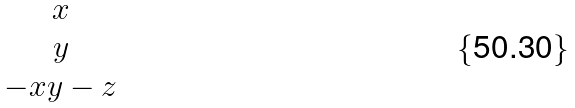<formula> <loc_0><loc_0><loc_500><loc_500>\begin{matrix} x \\ y \\ - x y - z \end{matrix}</formula> 